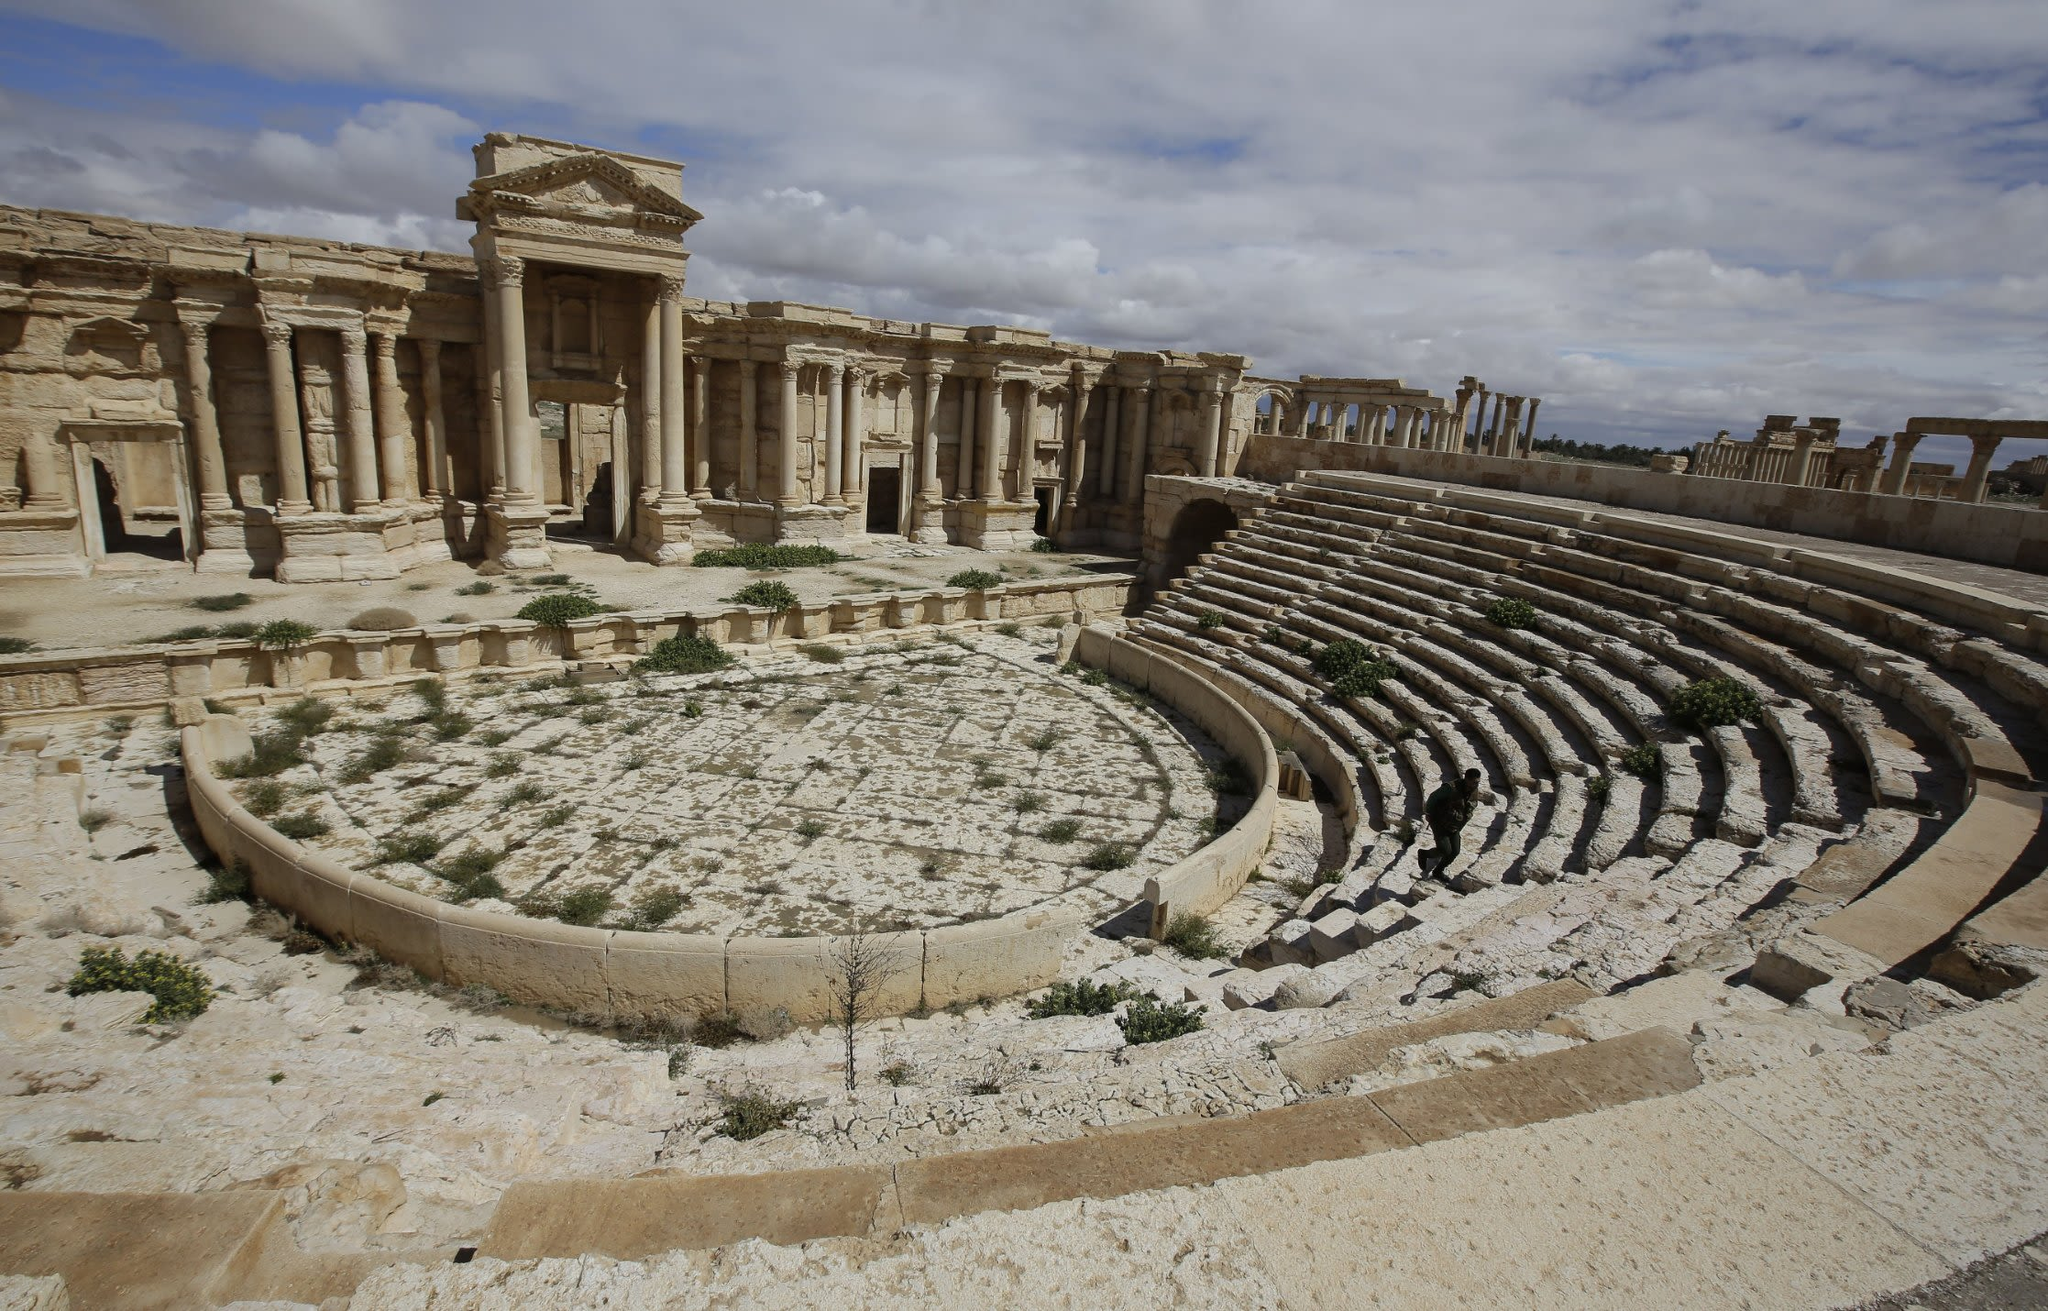What are the typical events or activities that would have been hosted in this theater historically? Historically, this theater in Palmyra would have hosted a variety of events, ranging from dramatic plays and musical concerts to important civic meetings and public announcements. Theaters in ancient Roman cities were central venues for both entertainment and public life, reflecting the cultural and social dynamics of the time. 